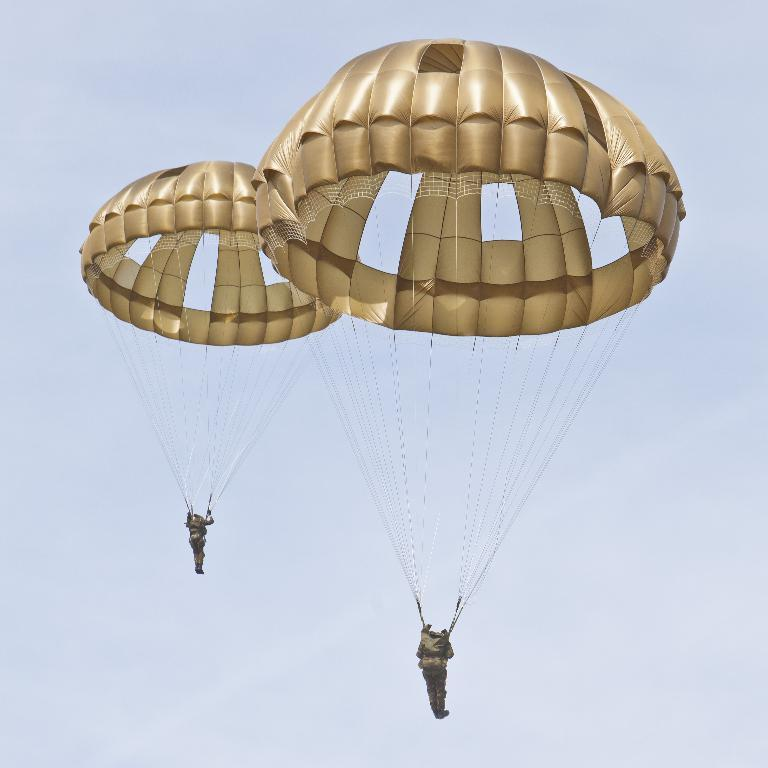How many people are in the image? There are two persons in the image. Where are the persons located in the image? The persons are in the air. What equipment do the persons have to ensure their safety while in the air? The persons have parachutes. What type of ray can be seen swimming in the water below the persons in the image? There is no ray or water visible in the image; the persons are in the air with parachutes. 